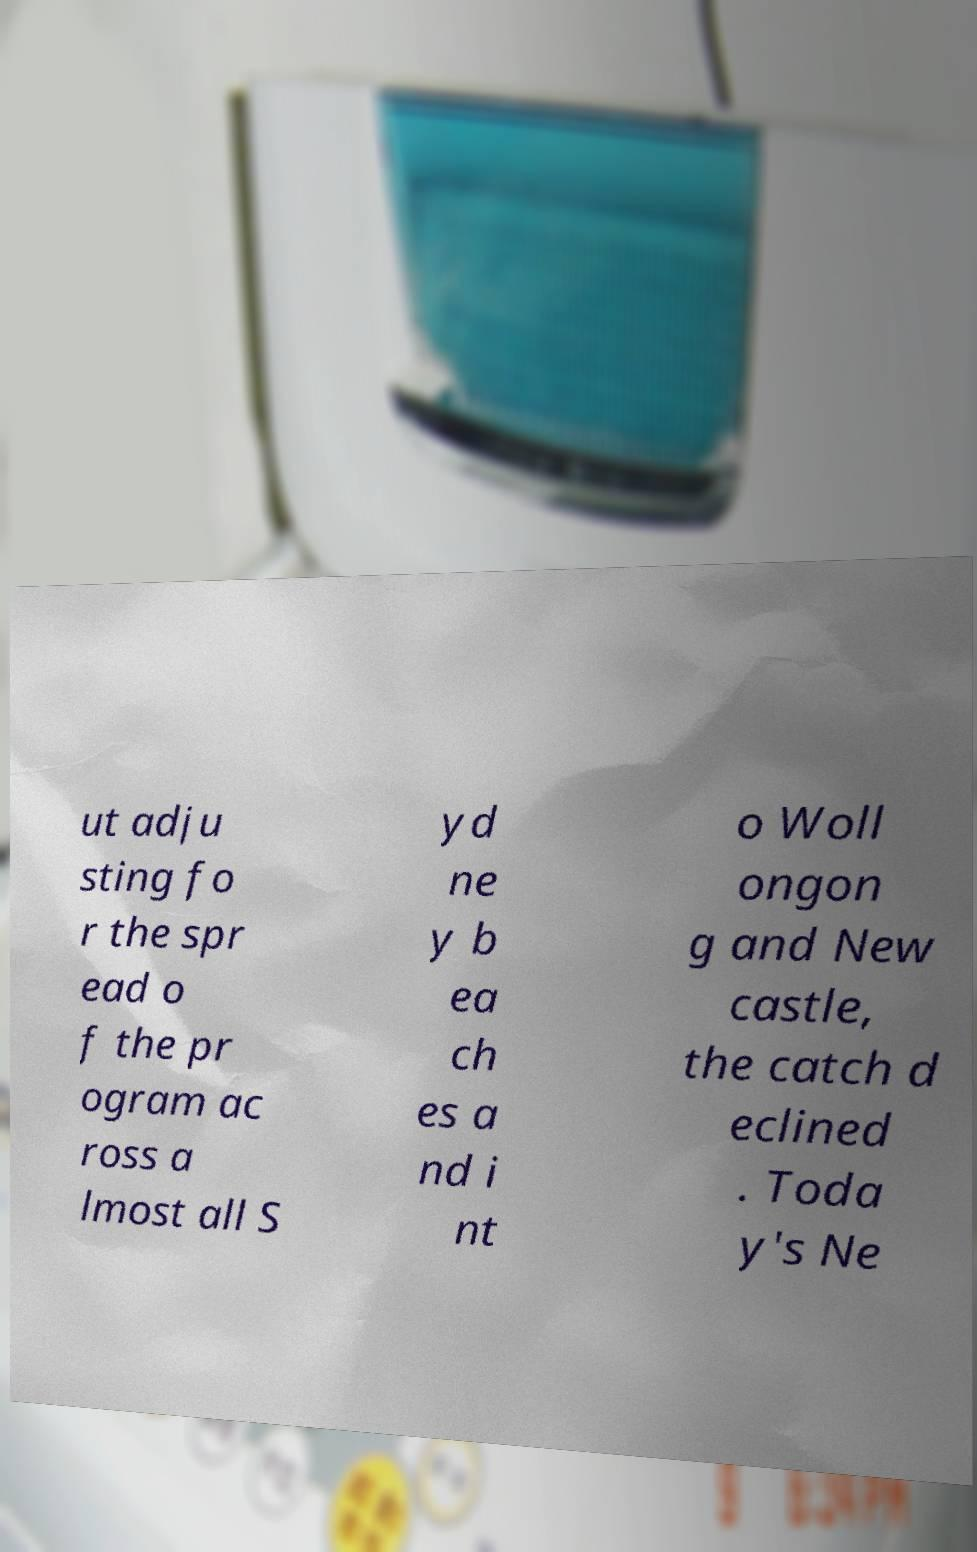Could you extract and type out the text from this image? ut adju sting fo r the spr ead o f the pr ogram ac ross a lmost all S yd ne y b ea ch es a nd i nt o Woll ongon g and New castle, the catch d eclined . Toda y's Ne 